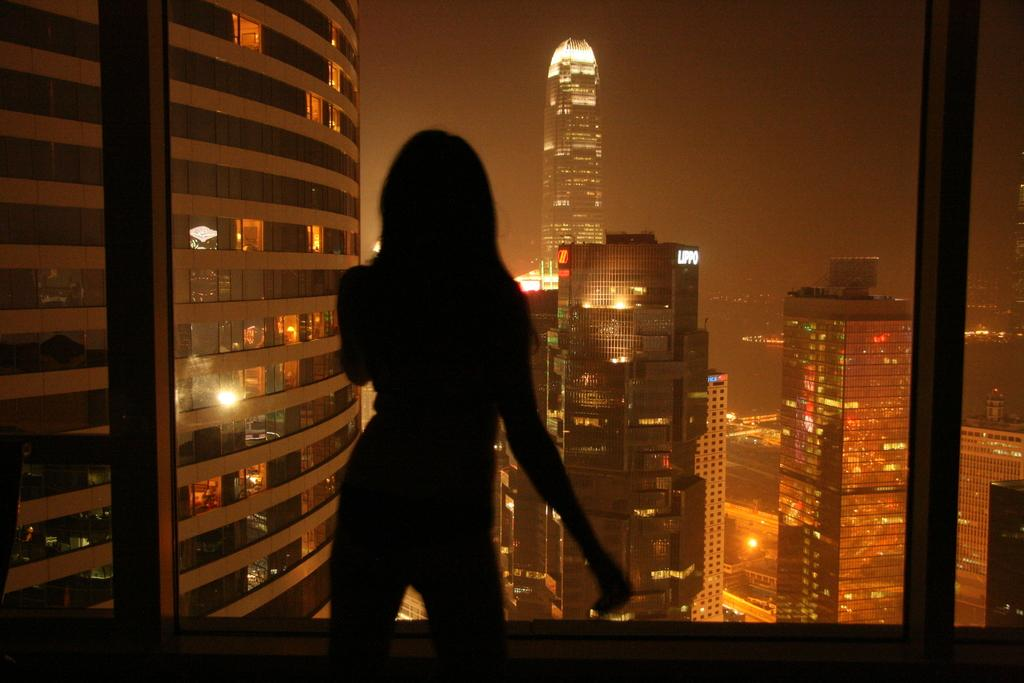Who is the main subject in the image? There is a lady in the center of the image. What can be seen in the background of the image? There are buildings in the background of the image. What is visible at the top of the image? The sky is visible at the top of the image. How many cherries are on the lady's shoes in the image? There are no cherries or shoes mentioned in the image; the lady is the main subject, and she is not wearing any shoes. 